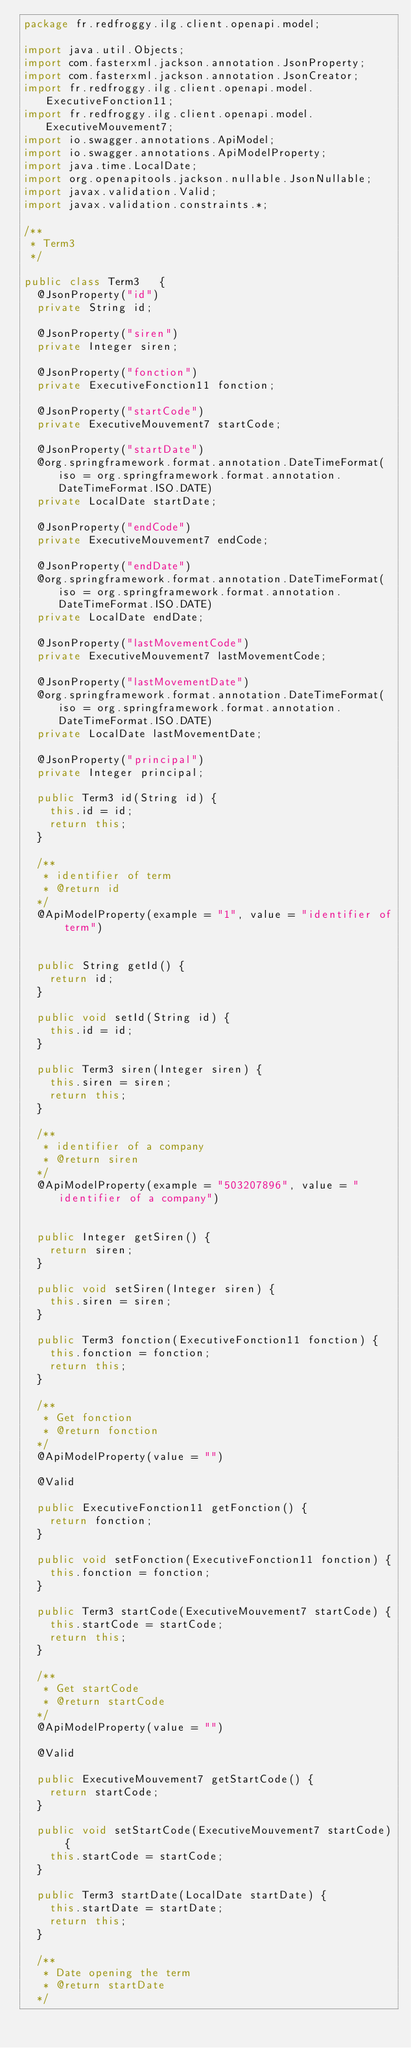Convert code to text. <code><loc_0><loc_0><loc_500><loc_500><_Java_>package fr.redfroggy.ilg.client.openapi.model;

import java.util.Objects;
import com.fasterxml.jackson.annotation.JsonProperty;
import com.fasterxml.jackson.annotation.JsonCreator;
import fr.redfroggy.ilg.client.openapi.model.ExecutiveFonction11;
import fr.redfroggy.ilg.client.openapi.model.ExecutiveMouvement7;
import io.swagger.annotations.ApiModel;
import io.swagger.annotations.ApiModelProperty;
import java.time.LocalDate;
import org.openapitools.jackson.nullable.JsonNullable;
import javax.validation.Valid;
import javax.validation.constraints.*;

/**
 * Term3
 */

public class Term3   {
  @JsonProperty("id")
  private String id;

  @JsonProperty("siren")
  private Integer siren;

  @JsonProperty("fonction")
  private ExecutiveFonction11 fonction;

  @JsonProperty("startCode")
  private ExecutiveMouvement7 startCode;

  @JsonProperty("startDate")
  @org.springframework.format.annotation.DateTimeFormat(iso = org.springframework.format.annotation.DateTimeFormat.ISO.DATE)
  private LocalDate startDate;

  @JsonProperty("endCode")
  private ExecutiveMouvement7 endCode;

  @JsonProperty("endDate")
  @org.springframework.format.annotation.DateTimeFormat(iso = org.springframework.format.annotation.DateTimeFormat.ISO.DATE)
  private LocalDate endDate;

  @JsonProperty("lastMovementCode")
  private ExecutiveMouvement7 lastMovementCode;

  @JsonProperty("lastMovementDate")
  @org.springframework.format.annotation.DateTimeFormat(iso = org.springframework.format.annotation.DateTimeFormat.ISO.DATE)
  private LocalDate lastMovementDate;

  @JsonProperty("principal")
  private Integer principal;

  public Term3 id(String id) {
    this.id = id;
    return this;
  }

  /**
   * identifier of term
   * @return id
  */
  @ApiModelProperty(example = "1", value = "identifier of term")


  public String getId() {
    return id;
  }

  public void setId(String id) {
    this.id = id;
  }

  public Term3 siren(Integer siren) {
    this.siren = siren;
    return this;
  }

  /**
   * identifier of a company
   * @return siren
  */
  @ApiModelProperty(example = "503207896", value = "identifier of a company")


  public Integer getSiren() {
    return siren;
  }

  public void setSiren(Integer siren) {
    this.siren = siren;
  }

  public Term3 fonction(ExecutiveFonction11 fonction) {
    this.fonction = fonction;
    return this;
  }

  /**
   * Get fonction
   * @return fonction
  */
  @ApiModelProperty(value = "")

  @Valid

  public ExecutiveFonction11 getFonction() {
    return fonction;
  }

  public void setFonction(ExecutiveFonction11 fonction) {
    this.fonction = fonction;
  }

  public Term3 startCode(ExecutiveMouvement7 startCode) {
    this.startCode = startCode;
    return this;
  }

  /**
   * Get startCode
   * @return startCode
  */
  @ApiModelProperty(value = "")

  @Valid

  public ExecutiveMouvement7 getStartCode() {
    return startCode;
  }

  public void setStartCode(ExecutiveMouvement7 startCode) {
    this.startCode = startCode;
  }

  public Term3 startDate(LocalDate startDate) {
    this.startDate = startDate;
    return this;
  }

  /**
   * Date opening the term
   * @return startDate
  */</code> 